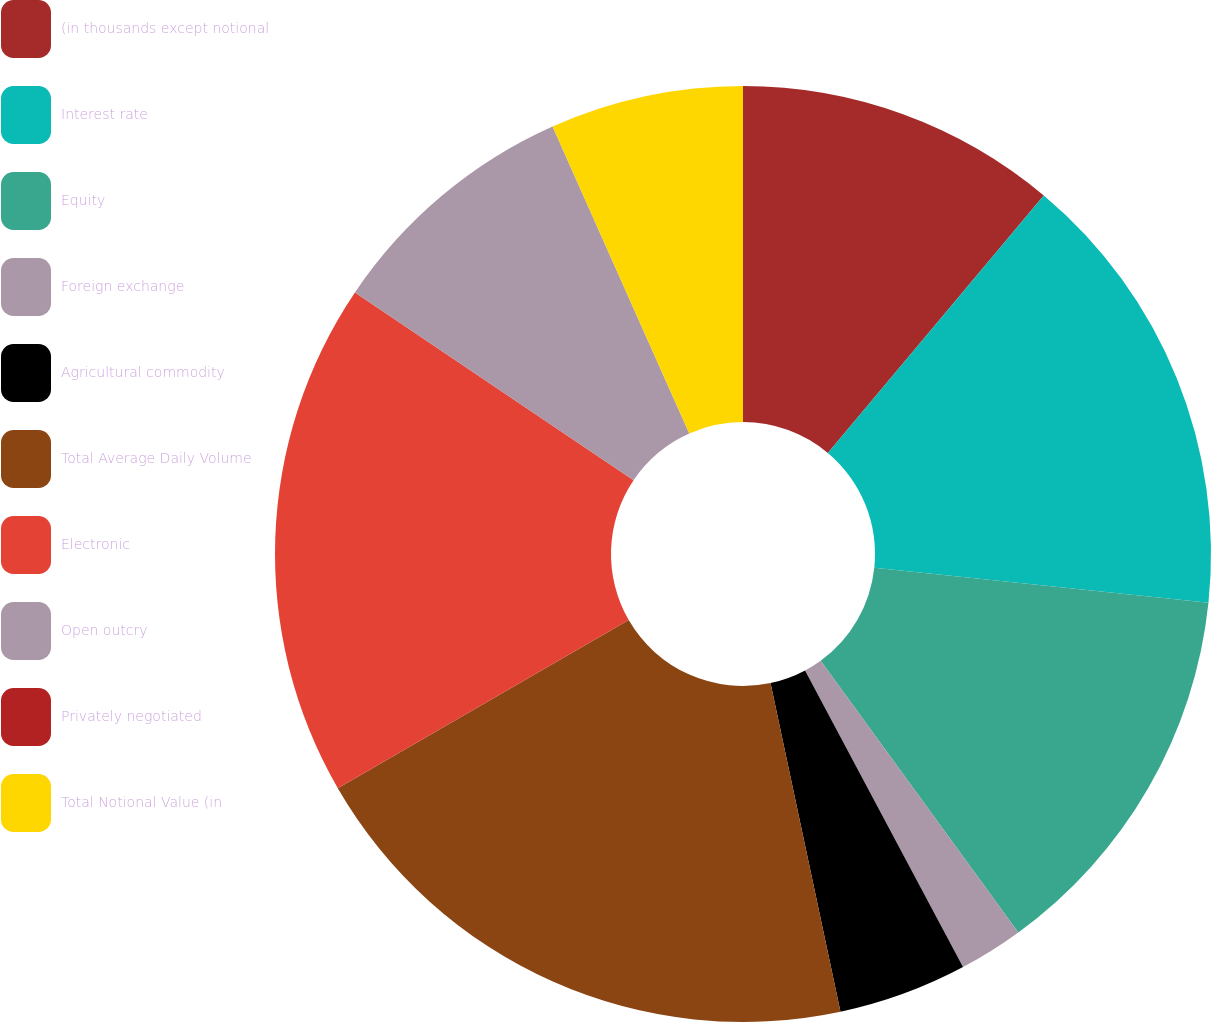<chart> <loc_0><loc_0><loc_500><loc_500><pie_chart><fcel>(in thousands except notional<fcel>Interest rate<fcel>Equity<fcel>Foreign exchange<fcel>Agricultural commodity<fcel>Total Average Daily Volume<fcel>Electronic<fcel>Open outcry<fcel>Privately negotiated<fcel>Total Notional Value (in<nl><fcel>11.11%<fcel>15.55%<fcel>13.33%<fcel>2.22%<fcel>4.45%<fcel>20.0%<fcel>17.78%<fcel>8.89%<fcel>0.0%<fcel>6.67%<nl></chart> 